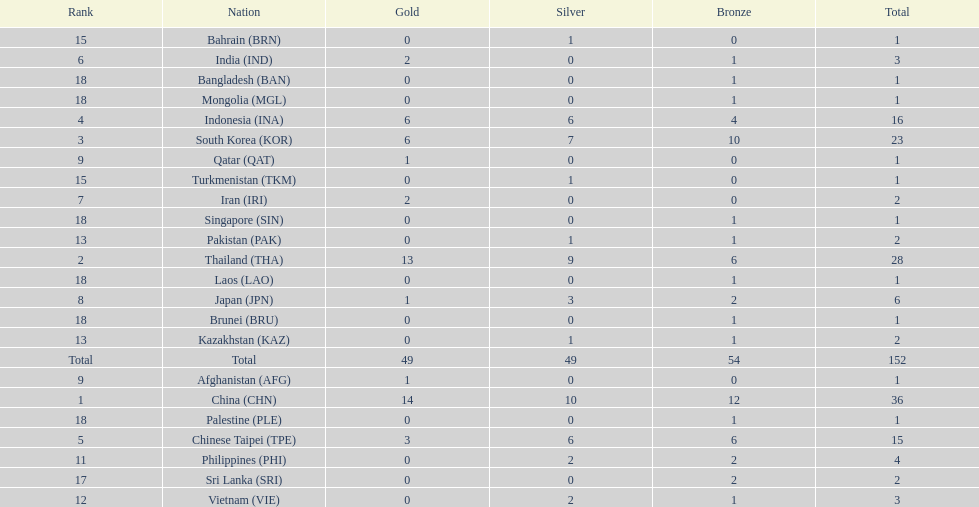What was the number of medals earned by indonesia (ina) ? 16. 